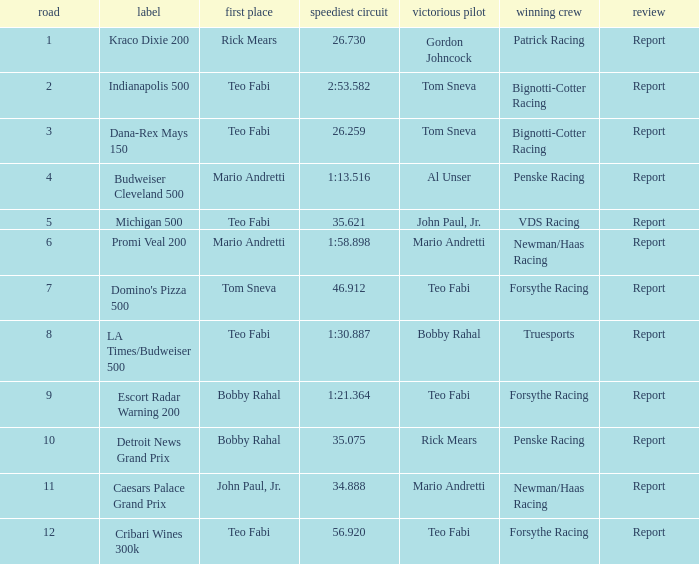What is the highest Rd that Tom Sneva had the pole position in? 7.0. 